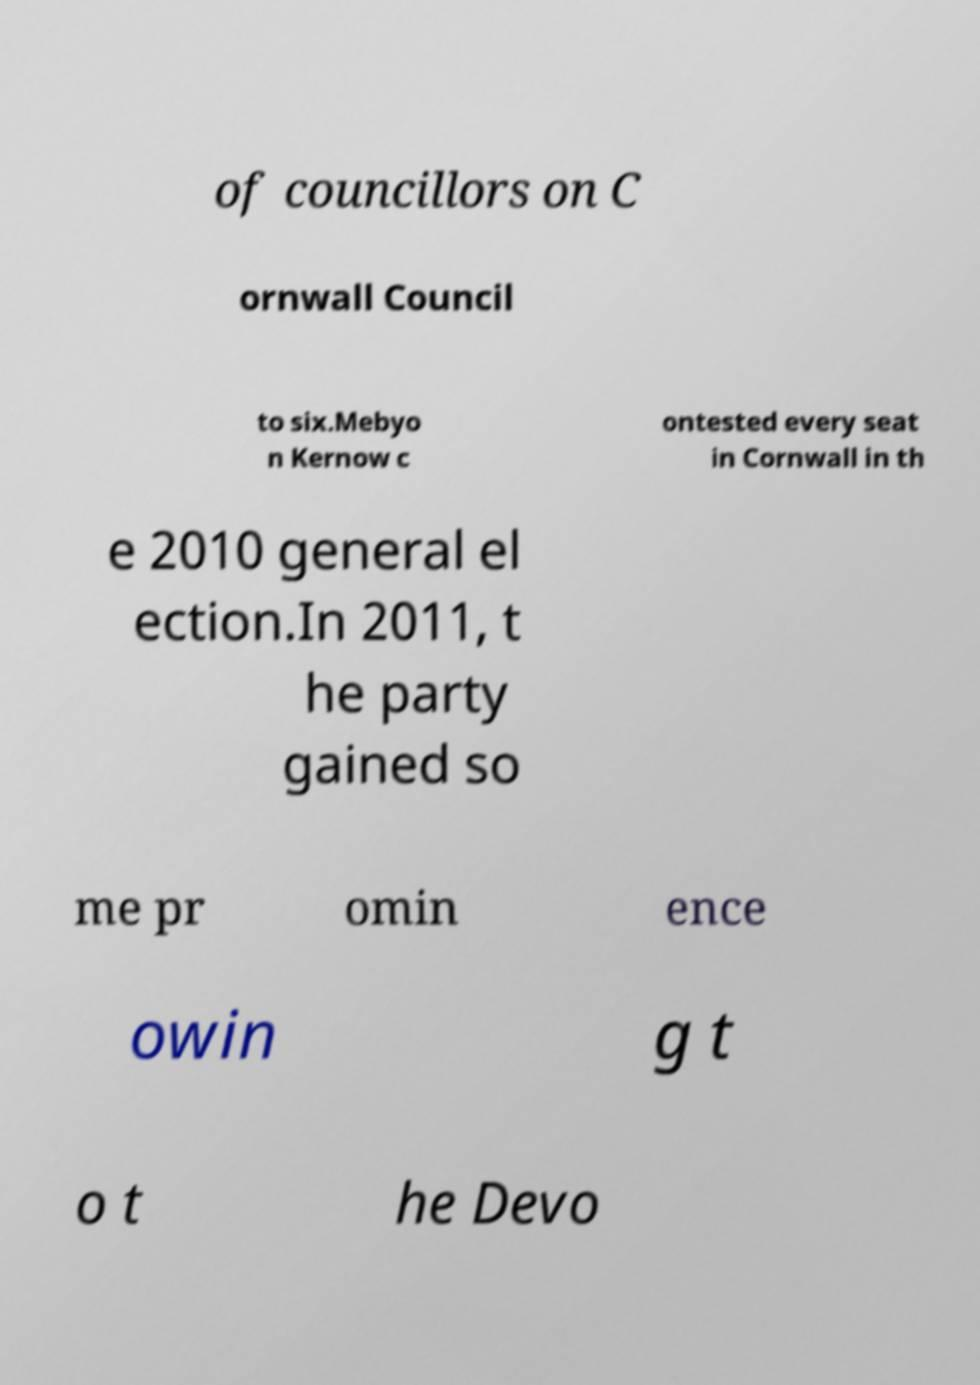Could you assist in decoding the text presented in this image and type it out clearly? of councillors on C ornwall Council to six.Mebyo n Kernow c ontested every seat in Cornwall in th e 2010 general el ection.In 2011, t he party gained so me pr omin ence owin g t o t he Devo 